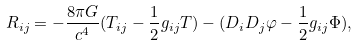Convert formula to latex. <formula><loc_0><loc_0><loc_500><loc_500>R _ { i j } = - \frac { 8 \pi G } { c ^ { 4 } } ( T _ { i j } - \frac { 1 } { 2 } g _ { i j } T ) - ( D _ { i } D _ { j } \varphi - \frac { 1 } { 2 } g _ { i j } \Phi ) ,</formula> 